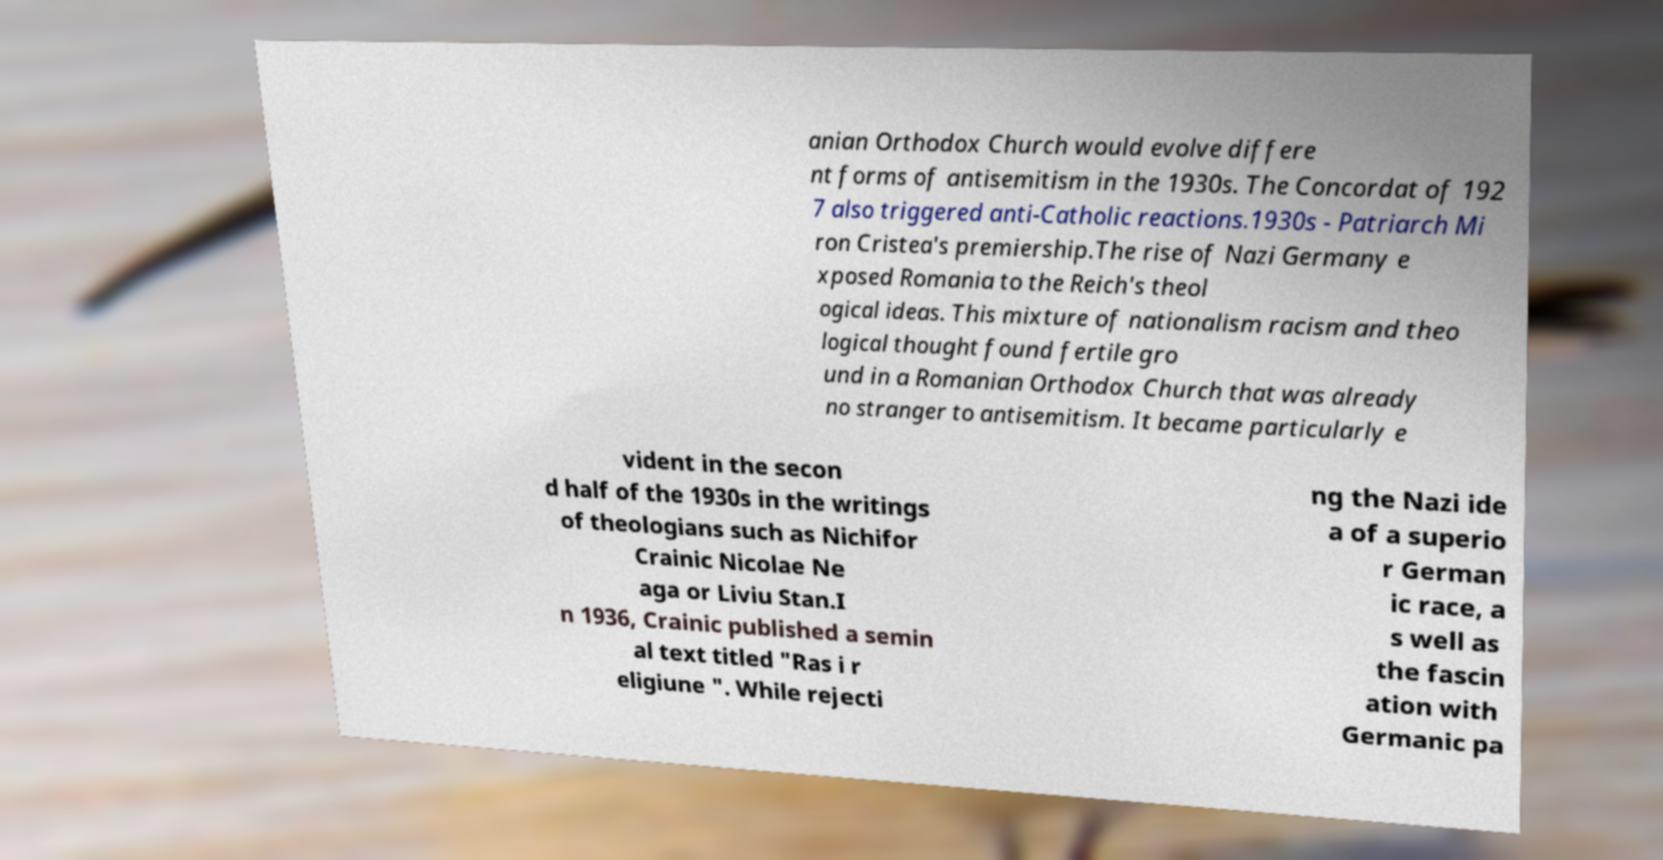There's text embedded in this image that I need extracted. Can you transcribe it verbatim? anian Orthodox Church would evolve differe nt forms of antisemitism in the 1930s. The Concordat of 192 7 also triggered anti-Catholic reactions.1930s - Patriarch Mi ron Cristea's premiership.The rise of Nazi Germany e xposed Romania to the Reich's theol ogical ideas. This mixture of nationalism racism and theo logical thought found fertile gro und in a Romanian Orthodox Church that was already no stranger to antisemitism. It became particularly e vident in the secon d half of the 1930s in the writings of theologians such as Nichifor Crainic Nicolae Ne aga or Liviu Stan.I n 1936, Crainic published a semin al text titled "Ras i r eligiune ". While rejecti ng the Nazi ide a of a superio r German ic race, a s well as the fascin ation with Germanic pa 